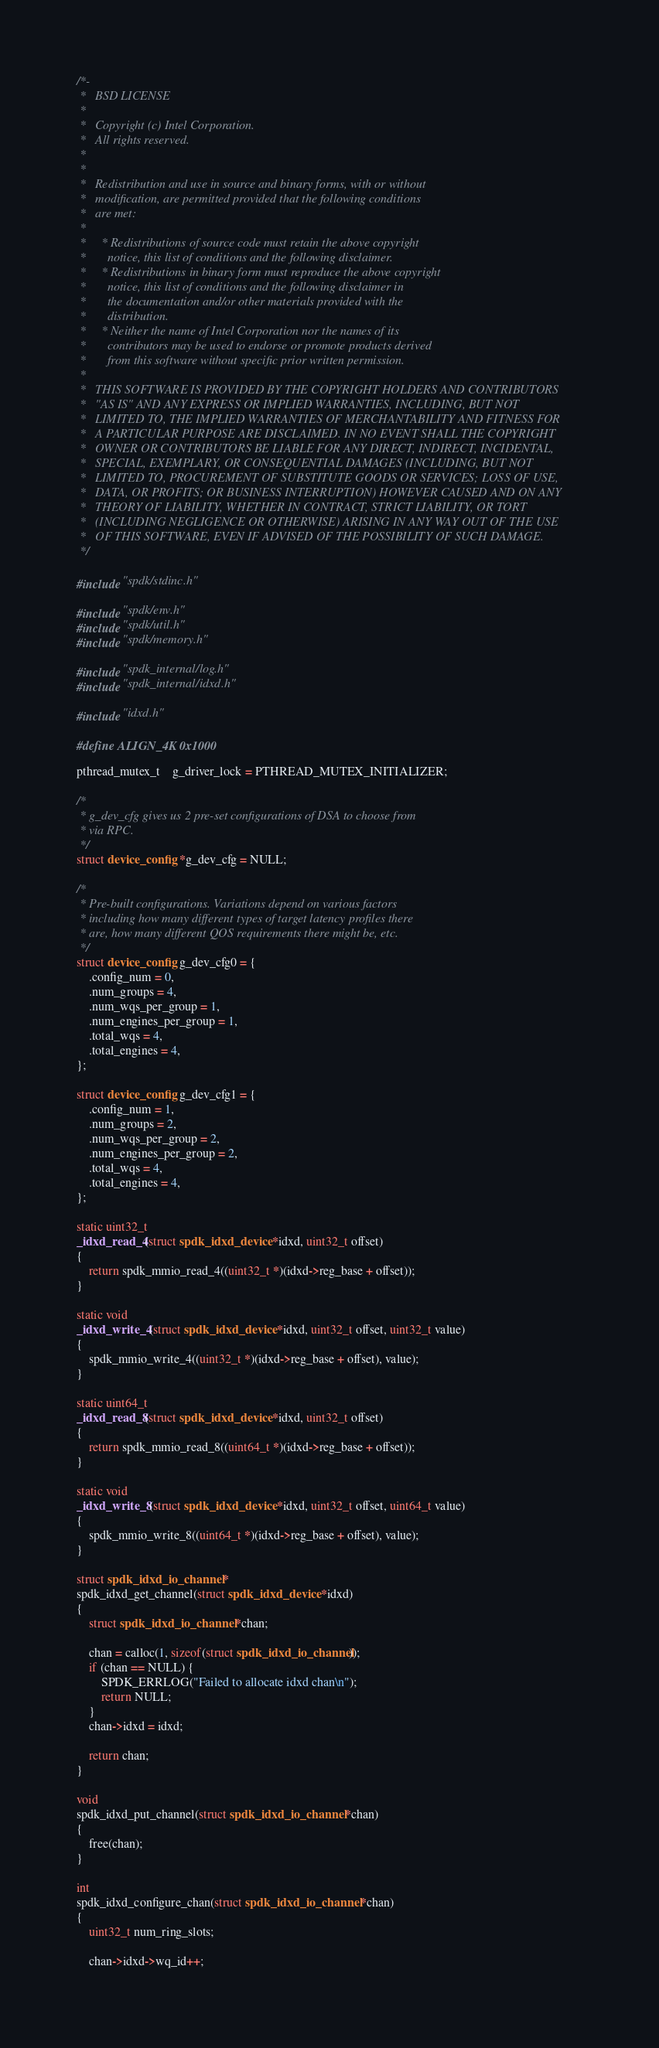<code> <loc_0><loc_0><loc_500><loc_500><_C_>/*-
 *   BSD LICENSE
 *
 *   Copyright (c) Intel Corporation.
 *   All rights reserved.
 *
 *
 *   Redistribution and use in source and binary forms, with or without
 *   modification, are permitted provided that the following conditions
 *   are met:
 *
 *     * Redistributions of source code must retain the above copyright
 *       notice, this list of conditions and the following disclaimer.
 *     * Redistributions in binary form must reproduce the above copyright
 *       notice, this list of conditions and the following disclaimer in
 *       the documentation and/or other materials provided with the
 *       distribution.
 *     * Neither the name of Intel Corporation nor the names of its
 *       contributors may be used to endorse or promote products derived
 *       from this software without specific prior written permission.
 *
 *   THIS SOFTWARE IS PROVIDED BY THE COPYRIGHT HOLDERS AND CONTRIBUTORS
 *   "AS IS" AND ANY EXPRESS OR IMPLIED WARRANTIES, INCLUDING, BUT NOT
 *   LIMITED TO, THE IMPLIED WARRANTIES OF MERCHANTABILITY AND FITNESS FOR
 *   A PARTICULAR PURPOSE ARE DISCLAIMED. IN NO EVENT SHALL THE COPYRIGHT
 *   OWNER OR CONTRIBUTORS BE LIABLE FOR ANY DIRECT, INDIRECT, INCIDENTAL,
 *   SPECIAL, EXEMPLARY, OR CONSEQUENTIAL DAMAGES (INCLUDING, BUT NOT
 *   LIMITED TO, PROCUREMENT OF SUBSTITUTE GOODS OR SERVICES; LOSS OF USE,
 *   DATA, OR PROFITS; OR BUSINESS INTERRUPTION) HOWEVER CAUSED AND ON ANY
 *   THEORY OF LIABILITY, WHETHER IN CONTRACT, STRICT LIABILITY, OR TORT
 *   (INCLUDING NEGLIGENCE OR OTHERWISE) ARISING IN ANY WAY OUT OF THE USE
 *   OF THIS SOFTWARE, EVEN IF ADVISED OF THE POSSIBILITY OF SUCH DAMAGE.
 */

#include "spdk/stdinc.h"

#include "spdk/env.h"
#include "spdk/util.h"
#include "spdk/memory.h"

#include "spdk_internal/log.h"
#include "spdk_internal/idxd.h"

#include "idxd.h"

#define ALIGN_4K 0x1000

pthread_mutex_t	g_driver_lock = PTHREAD_MUTEX_INITIALIZER;

/*
 * g_dev_cfg gives us 2 pre-set configurations of DSA to choose from
 * via RPC.
 */
struct device_config *g_dev_cfg = NULL;

/*
 * Pre-built configurations. Variations depend on various factors
 * including how many different types of target latency profiles there
 * are, how many different QOS requirements there might be, etc.
 */
struct device_config g_dev_cfg0 = {
	.config_num = 0,
	.num_groups = 4,
	.num_wqs_per_group = 1,
	.num_engines_per_group = 1,
	.total_wqs = 4,
	.total_engines = 4,
};

struct device_config g_dev_cfg1 = {
	.config_num = 1,
	.num_groups = 2,
	.num_wqs_per_group = 2,
	.num_engines_per_group = 2,
	.total_wqs = 4,
	.total_engines = 4,
};

static uint32_t
_idxd_read_4(struct spdk_idxd_device *idxd, uint32_t offset)
{
	return spdk_mmio_read_4((uint32_t *)(idxd->reg_base + offset));
}

static void
_idxd_write_4(struct spdk_idxd_device *idxd, uint32_t offset, uint32_t value)
{
	spdk_mmio_write_4((uint32_t *)(idxd->reg_base + offset), value);
}

static uint64_t
_idxd_read_8(struct spdk_idxd_device *idxd, uint32_t offset)
{
	return spdk_mmio_read_8((uint64_t *)(idxd->reg_base + offset));
}

static void
_idxd_write_8(struct spdk_idxd_device *idxd, uint32_t offset, uint64_t value)
{
	spdk_mmio_write_8((uint64_t *)(idxd->reg_base + offset), value);
}

struct spdk_idxd_io_channel *
spdk_idxd_get_channel(struct spdk_idxd_device *idxd)
{
	struct spdk_idxd_io_channel *chan;

	chan = calloc(1, sizeof(struct spdk_idxd_io_channel));
	if (chan == NULL) {
		SPDK_ERRLOG("Failed to allocate idxd chan\n");
		return NULL;
	}
	chan->idxd = idxd;

	return chan;
}

void
spdk_idxd_put_channel(struct spdk_idxd_io_channel *chan)
{
	free(chan);
}

int
spdk_idxd_configure_chan(struct spdk_idxd_io_channel *chan)
{
	uint32_t num_ring_slots;

	chan->idxd->wq_id++;</code> 